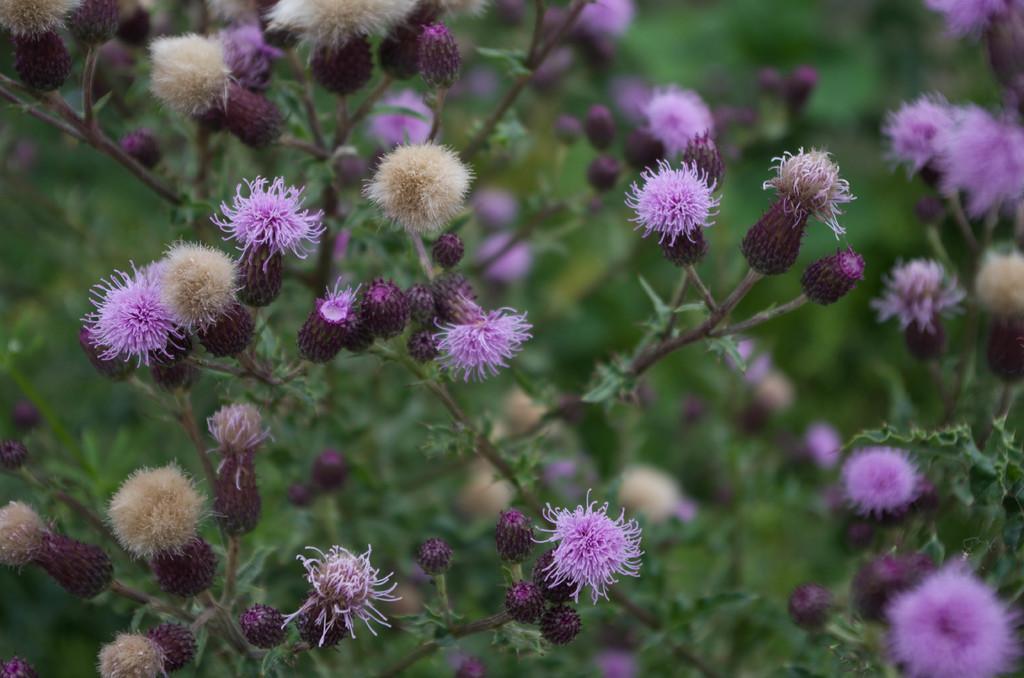Describe this image in one or two sentences. In this picture I can observe violet color flowers in the middle of the picture. The background is blurred. 